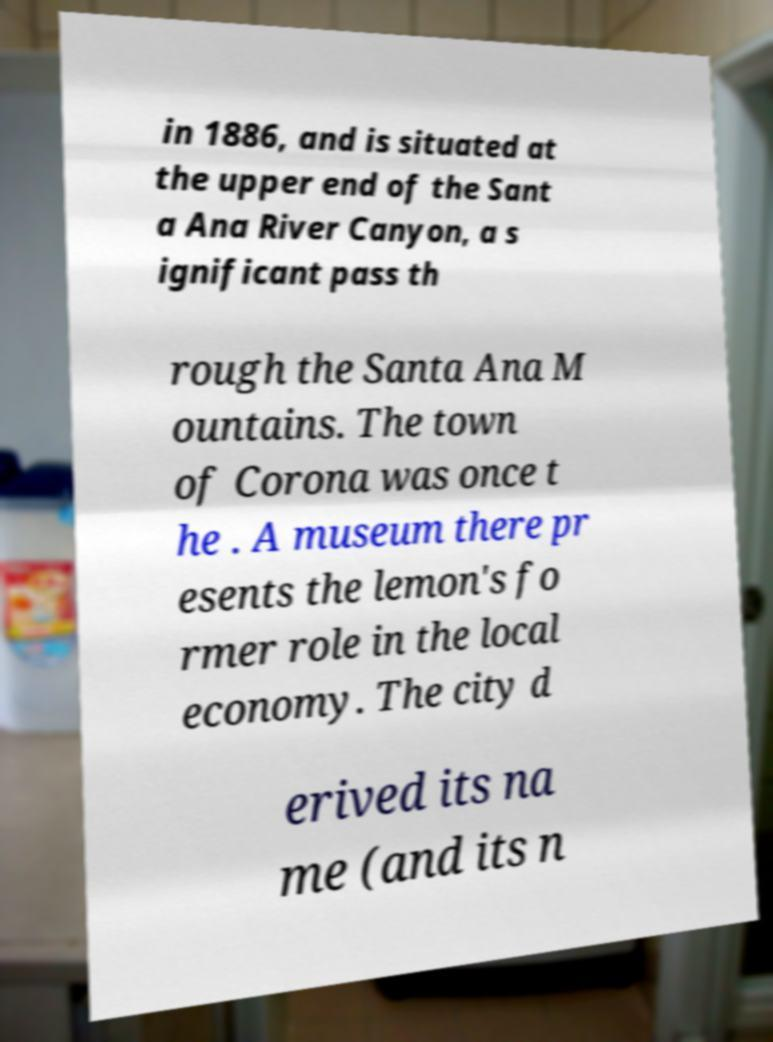Can you accurately transcribe the text from the provided image for me? in 1886, and is situated at the upper end of the Sant a Ana River Canyon, a s ignificant pass th rough the Santa Ana M ountains. The town of Corona was once t he . A museum there pr esents the lemon's fo rmer role in the local economy. The city d erived its na me (and its n 